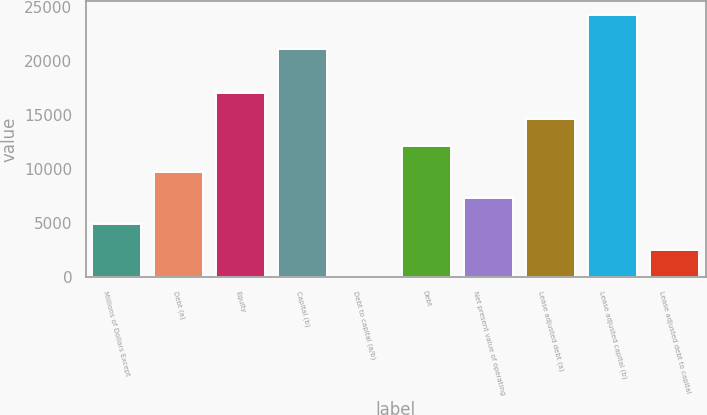Convert chart. <chart><loc_0><loc_0><loc_500><loc_500><bar_chart><fcel>Millions of Dollars Except<fcel>Debt (a)<fcel>Equity<fcel>Capital (b)<fcel>Debt to capital (a/b)<fcel>Debt<fcel>Net present value of operating<fcel>Lease adjusted debt (a)<fcel>Lease adjusted capital (b)<fcel>Lease adjusted debt to capital<nl><fcel>4889.68<fcel>9744.26<fcel>17026.1<fcel>21123<fcel>35.1<fcel>12171.5<fcel>7316.97<fcel>14598.8<fcel>24308<fcel>2462.39<nl></chart> 